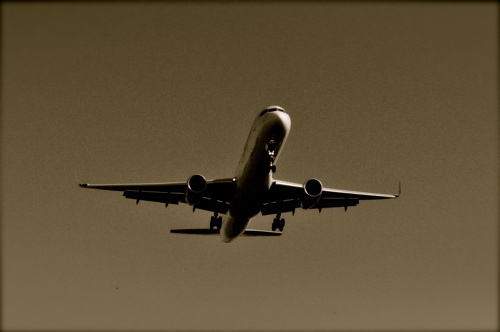<image>Who is the photographer? It is unknown who the photographer is. What does the plane say above the wing? It is ambiguous what the plane says above the wing. It could be United, Delta, American or nothing. Who is the photographer? I don't know who is the photographer. It can be anyone, such as the airport photographer, the man on the ground, or an airline worker. What does the plane say above the wing? I am not sure what the plane says above the wing. It can be seen 'united', 'delta', or 'american'. 